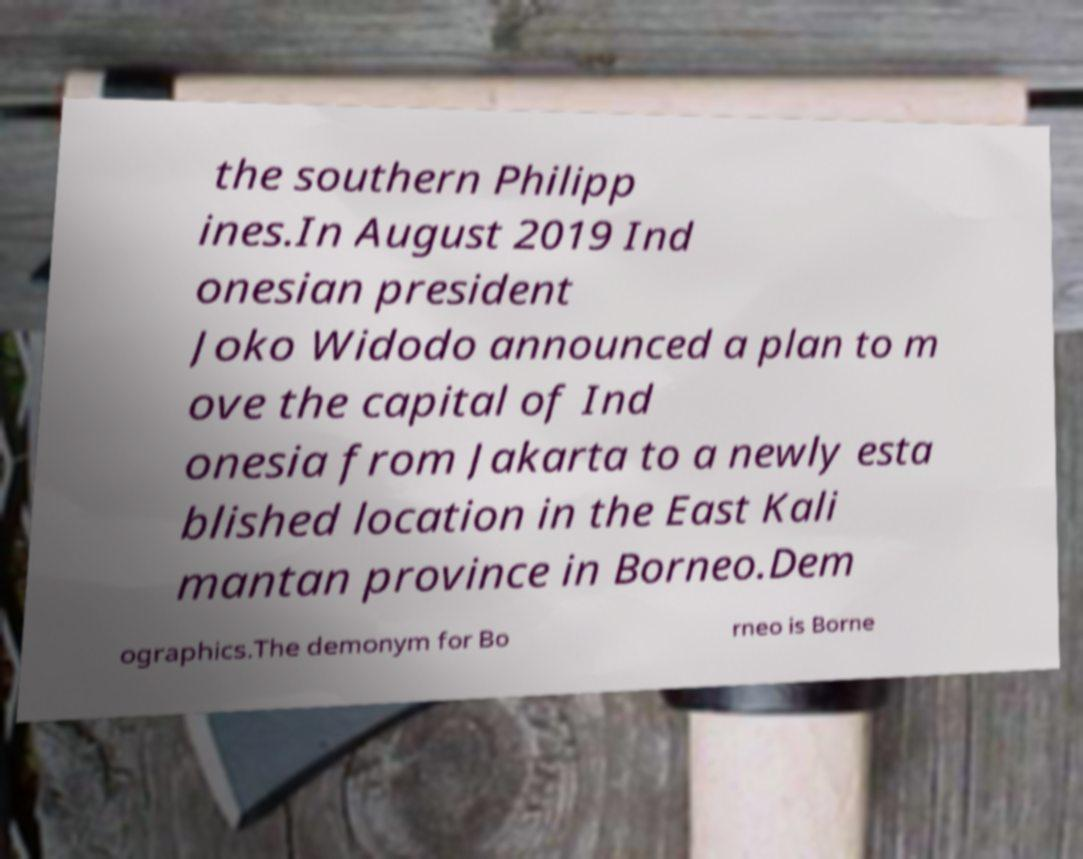I need the written content from this picture converted into text. Can you do that? the southern Philipp ines.In August 2019 Ind onesian president Joko Widodo announced a plan to m ove the capital of Ind onesia from Jakarta to a newly esta blished location in the East Kali mantan province in Borneo.Dem ographics.The demonym for Bo rneo is Borne 